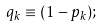Convert formula to latex. <formula><loc_0><loc_0><loc_500><loc_500>q _ { k } \equiv ( 1 - p _ { k } ) ;</formula> 